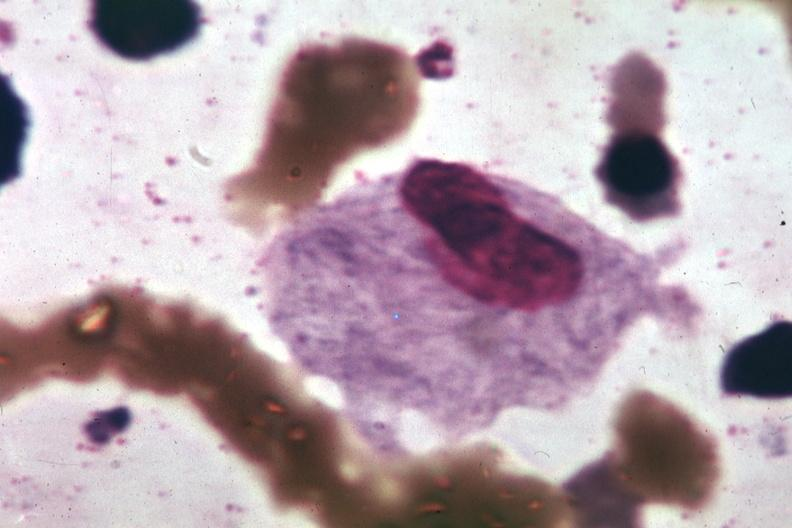what is present?
Answer the question using a single word or phrase. Hematologic 